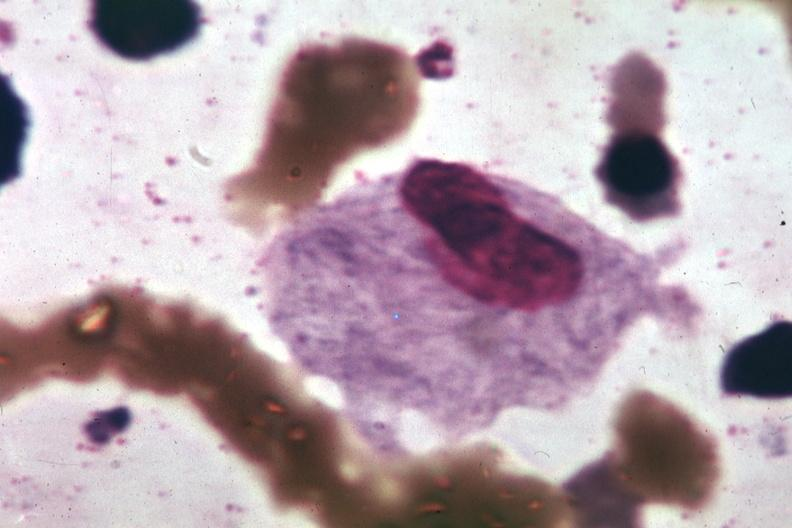what is present?
Answer the question using a single word or phrase. Hematologic 